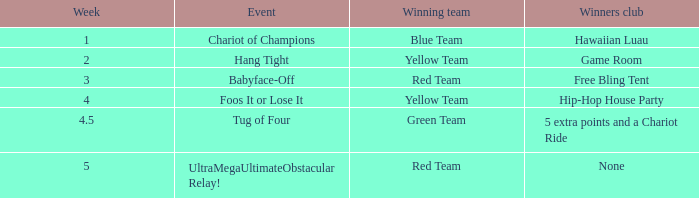Which Week has an Air Date of august 30, 2008? 5.0. 